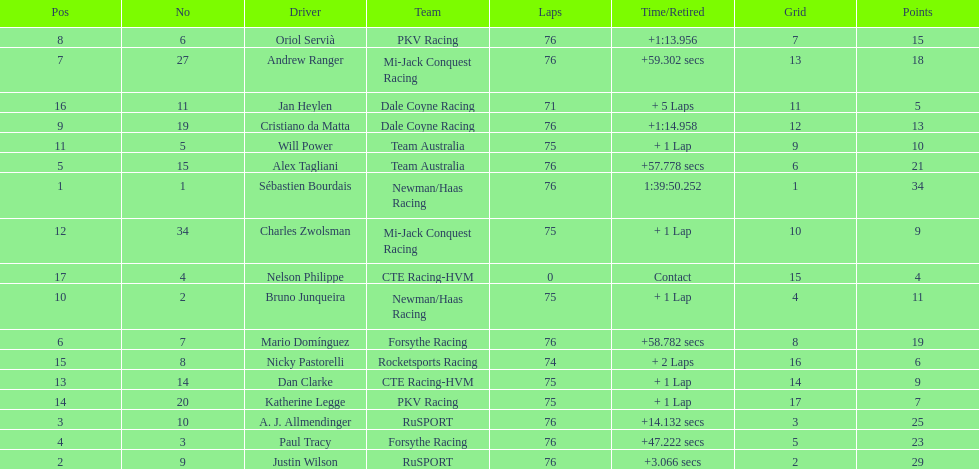What driver earned the most points? Sebastien Bourdais. 